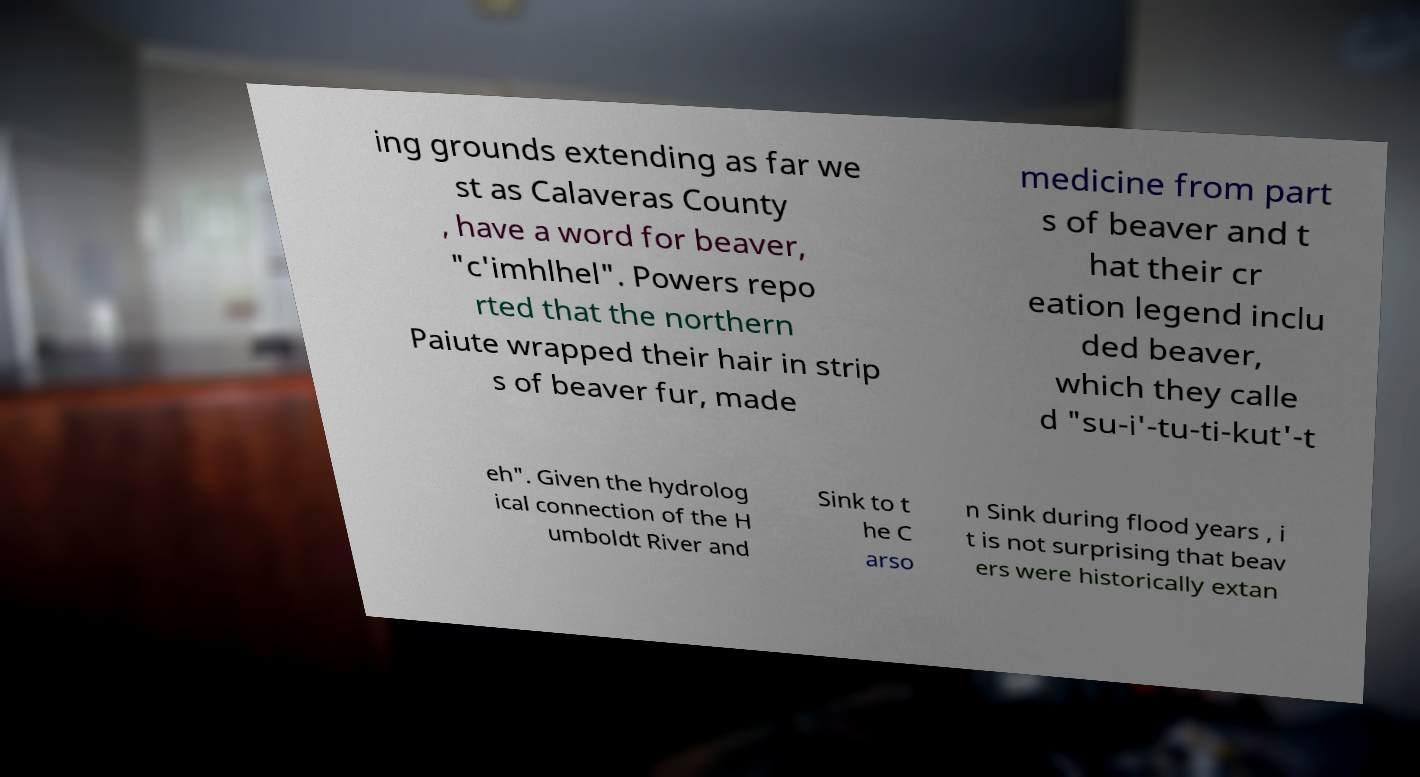For documentation purposes, I need the text within this image transcribed. Could you provide that? ing grounds extending as far we st as Calaveras County , have a word for beaver, "c'imhlhel". Powers repo rted that the northern Paiute wrapped their hair in strip s of beaver fur, made medicine from part s of beaver and t hat their cr eation legend inclu ded beaver, which they calle d "su-i'-tu-ti-kut'-t eh". Given the hydrolog ical connection of the H umboldt River and Sink to t he C arso n Sink during flood years , i t is not surprising that beav ers were historically extan 